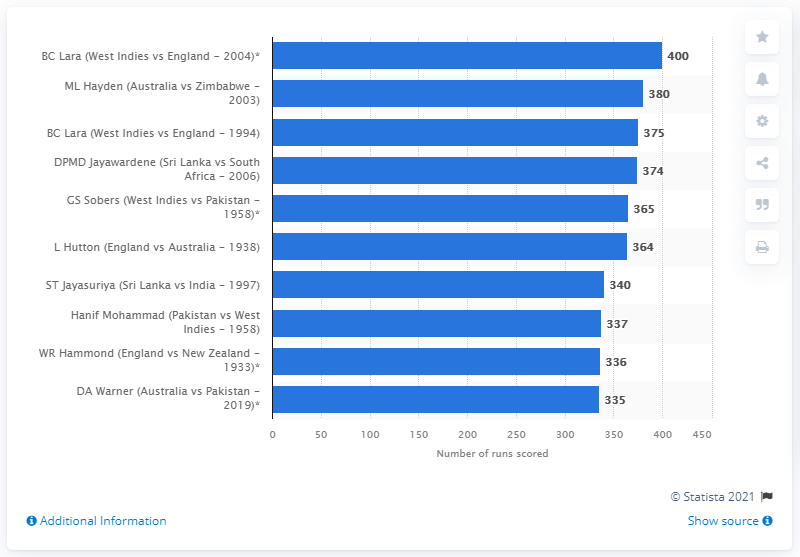Give some essential details in this illustration. Brian Lara scored 400 runs against England in 2004, a remarkable achievement that cemented his status as one of the greatest batsmen in the history of the game. 